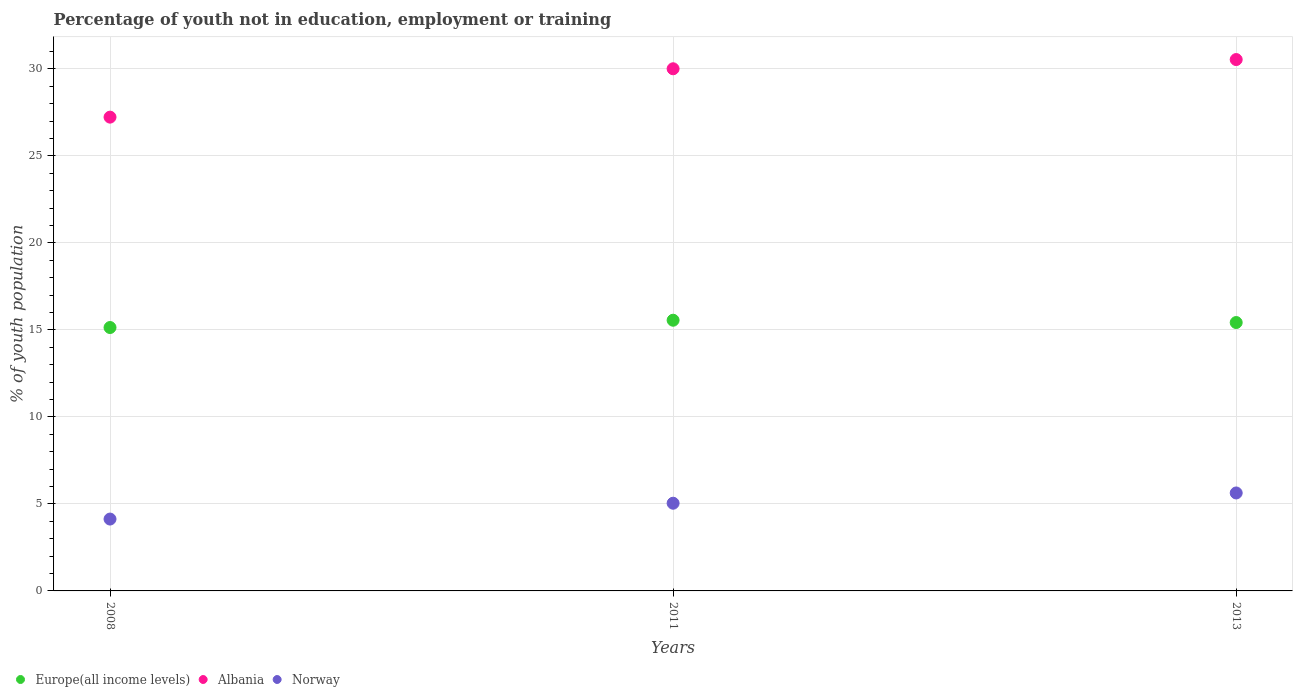How many different coloured dotlines are there?
Give a very brief answer. 3. Is the number of dotlines equal to the number of legend labels?
Your response must be concise. Yes. What is the percentage of unemployed youth population in in Albania in 2013?
Give a very brief answer. 30.54. Across all years, what is the maximum percentage of unemployed youth population in in Albania?
Make the answer very short. 30.54. Across all years, what is the minimum percentage of unemployed youth population in in Norway?
Your response must be concise. 4.13. In which year was the percentage of unemployed youth population in in Albania maximum?
Provide a short and direct response. 2013. In which year was the percentage of unemployed youth population in in Europe(all income levels) minimum?
Ensure brevity in your answer.  2008. What is the total percentage of unemployed youth population in in Europe(all income levels) in the graph?
Offer a terse response. 46.12. What is the difference between the percentage of unemployed youth population in in Albania in 2008 and that in 2013?
Keep it short and to the point. -3.31. What is the difference between the percentage of unemployed youth population in in Albania in 2011 and the percentage of unemployed youth population in in Norway in 2013?
Your answer should be compact. 24.38. What is the average percentage of unemployed youth population in in Norway per year?
Make the answer very short. 4.93. In the year 2011, what is the difference between the percentage of unemployed youth population in in Albania and percentage of unemployed youth population in in Europe(all income levels)?
Your response must be concise. 14.45. In how many years, is the percentage of unemployed youth population in in Europe(all income levels) greater than 6 %?
Your answer should be compact. 3. What is the ratio of the percentage of unemployed youth population in in Norway in 2008 to that in 2013?
Provide a succinct answer. 0.73. Is the difference between the percentage of unemployed youth population in in Albania in 2011 and 2013 greater than the difference between the percentage of unemployed youth population in in Europe(all income levels) in 2011 and 2013?
Keep it short and to the point. No. What is the difference between the highest and the second highest percentage of unemployed youth population in in Albania?
Your response must be concise. 0.53. What is the difference between the highest and the lowest percentage of unemployed youth population in in Norway?
Your answer should be compact. 1.5. Is the sum of the percentage of unemployed youth population in in Europe(all income levels) in 2011 and 2013 greater than the maximum percentage of unemployed youth population in in Albania across all years?
Provide a short and direct response. Yes. Is it the case that in every year, the sum of the percentage of unemployed youth population in in Norway and percentage of unemployed youth population in in Albania  is greater than the percentage of unemployed youth population in in Europe(all income levels)?
Give a very brief answer. Yes. Does the percentage of unemployed youth population in in Albania monotonically increase over the years?
Your answer should be compact. Yes. How many dotlines are there?
Your answer should be very brief. 3. How many years are there in the graph?
Your answer should be compact. 3. Does the graph contain any zero values?
Your answer should be compact. No. How many legend labels are there?
Provide a short and direct response. 3. What is the title of the graph?
Your answer should be compact. Percentage of youth not in education, employment or training. Does "Ecuador" appear as one of the legend labels in the graph?
Provide a succinct answer. No. What is the label or title of the X-axis?
Give a very brief answer. Years. What is the label or title of the Y-axis?
Make the answer very short. % of youth population. What is the % of youth population in Europe(all income levels) in 2008?
Provide a short and direct response. 15.14. What is the % of youth population of Albania in 2008?
Offer a terse response. 27.23. What is the % of youth population of Norway in 2008?
Your answer should be compact. 4.13. What is the % of youth population in Europe(all income levels) in 2011?
Your answer should be very brief. 15.56. What is the % of youth population in Albania in 2011?
Provide a short and direct response. 30.01. What is the % of youth population of Norway in 2011?
Ensure brevity in your answer.  5.04. What is the % of youth population of Europe(all income levels) in 2013?
Make the answer very short. 15.43. What is the % of youth population of Albania in 2013?
Give a very brief answer. 30.54. What is the % of youth population of Norway in 2013?
Your answer should be compact. 5.63. Across all years, what is the maximum % of youth population in Europe(all income levels)?
Offer a very short reply. 15.56. Across all years, what is the maximum % of youth population of Albania?
Make the answer very short. 30.54. Across all years, what is the maximum % of youth population in Norway?
Provide a short and direct response. 5.63. Across all years, what is the minimum % of youth population in Europe(all income levels)?
Offer a terse response. 15.14. Across all years, what is the minimum % of youth population of Albania?
Give a very brief answer. 27.23. Across all years, what is the minimum % of youth population in Norway?
Give a very brief answer. 4.13. What is the total % of youth population of Europe(all income levels) in the graph?
Keep it short and to the point. 46.12. What is the total % of youth population in Albania in the graph?
Give a very brief answer. 87.78. What is the difference between the % of youth population in Europe(all income levels) in 2008 and that in 2011?
Your response must be concise. -0.42. What is the difference between the % of youth population in Albania in 2008 and that in 2011?
Offer a very short reply. -2.78. What is the difference between the % of youth population of Norway in 2008 and that in 2011?
Keep it short and to the point. -0.91. What is the difference between the % of youth population in Europe(all income levels) in 2008 and that in 2013?
Your answer should be very brief. -0.29. What is the difference between the % of youth population in Albania in 2008 and that in 2013?
Offer a very short reply. -3.31. What is the difference between the % of youth population of Norway in 2008 and that in 2013?
Your response must be concise. -1.5. What is the difference between the % of youth population in Europe(all income levels) in 2011 and that in 2013?
Your answer should be compact. 0.13. What is the difference between the % of youth population of Albania in 2011 and that in 2013?
Provide a succinct answer. -0.53. What is the difference between the % of youth population of Norway in 2011 and that in 2013?
Give a very brief answer. -0.59. What is the difference between the % of youth population in Europe(all income levels) in 2008 and the % of youth population in Albania in 2011?
Ensure brevity in your answer.  -14.87. What is the difference between the % of youth population in Europe(all income levels) in 2008 and the % of youth population in Norway in 2011?
Make the answer very short. 10.1. What is the difference between the % of youth population of Albania in 2008 and the % of youth population of Norway in 2011?
Make the answer very short. 22.19. What is the difference between the % of youth population of Europe(all income levels) in 2008 and the % of youth population of Albania in 2013?
Provide a succinct answer. -15.4. What is the difference between the % of youth population in Europe(all income levels) in 2008 and the % of youth population in Norway in 2013?
Keep it short and to the point. 9.51. What is the difference between the % of youth population in Albania in 2008 and the % of youth population in Norway in 2013?
Offer a very short reply. 21.6. What is the difference between the % of youth population in Europe(all income levels) in 2011 and the % of youth population in Albania in 2013?
Your answer should be compact. -14.98. What is the difference between the % of youth population in Europe(all income levels) in 2011 and the % of youth population in Norway in 2013?
Provide a succinct answer. 9.93. What is the difference between the % of youth population of Albania in 2011 and the % of youth population of Norway in 2013?
Your answer should be very brief. 24.38. What is the average % of youth population of Europe(all income levels) per year?
Your answer should be compact. 15.37. What is the average % of youth population of Albania per year?
Give a very brief answer. 29.26. What is the average % of youth population in Norway per year?
Offer a terse response. 4.93. In the year 2008, what is the difference between the % of youth population of Europe(all income levels) and % of youth population of Albania?
Offer a terse response. -12.09. In the year 2008, what is the difference between the % of youth population in Europe(all income levels) and % of youth population in Norway?
Your answer should be very brief. 11.01. In the year 2008, what is the difference between the % of youth population in Albania and % of youth population in Norway?
Provide a short and direct response. 23.1. In the year 2011, what is the difference between the % of youth population in Europe(all income levels) and % of youth population in Albania?
Your answer should be very brief. -14.45. In the year 2011, what is the difference between the % of youth population of Europe(all income levels) and % of youth population of Norway?
Offer a very short reply. 10.52. In the year 2011, what is the difference between the % of youth population in Albania and % of youth population in Norway?
Keep it short and to the point. 24.97. In the year 2013, what is the difference between the % of youth population in Europe(all income levels) and % of youth population in Albania?
Your answer should be compact. -15.11. In the year 2013, what is the difference between the % of youth population of Europe(all income levels) and % of youth population of Norway?
Provide a short and direct response. 9.8. In the year 2013, what is the difference between the % of youth population of Albania and % of youth population of Norway?
Provide a succinct answer. 24.91. What is the ratio of the % of youth population of Europe(all income levels) in 2008 to that in 2011?
Keep it short and to the point. 0.97. What is the ratio of the % of youth population in Albania in 2008 to that in 2011?
Provide a short and direct response. 0.91. What is the ratio of the % of youth population in Norway in 2008 to that in 2011?
Your answer should be very brief. 0.82. What is the ratio of the % of youth population of Europe(all income levels) in 2008 to that in 2013?
Your answer should be compact. 0.98. What is the ratio of the % of youth population in Albania in 2008 to that in 2013?
Offer a terse response. 0.89. What is the ratio of the % of youth population in Norway in 2008 to that in 2013?
Provide a short and direct response. 0.73. What is the ratio of the % of youth population of Europe(all income levels) in 2011 to that in 2013?
Keep it short and to the point. 1.01. What is the ratio of the % of youth population in Albania in 2011 to that in 2013?
Ensure brevity in your answer.  0.98. What is the ratio of the % of youth population of Norway in 2011 to that in 2013?
Your response must be concise. 0.9. What is the difference between the highest and the second highest % of youth population in Europe(all income levels)?
Provide a short and direct response. 0.13. What is the difference between the highest and the second highest % of youth population in Albania?
Your answer should be very brief. 0.53. What is the difference between the highest and the second highest % of youth population of Norway?
Ensure brevity in your answer.  0.59. What is the difference between the highest and the lowest % of youth population in Europe(all income levels)?
Your response must be concise. 0.42. What is the difference between the highest and the lowest % of youth population in Albania?
Keep it short and to the point. 3.31. 